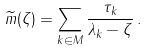Convert formula to latex. <formula><loc_0><loc_0><loc_500><loc_500>\widetilde { m } ( \zeta ) = \sum _ { k \in M } \frac { \tau _ { k } } { \lambda _ { k } - \zeta } \, .</formula> 